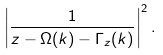Convert formula to latex. <formula><loc_0><loc_0><loc_500><loc_500>\left | \frac { 1 } { z - \Omega ( k ) - \Gamma _ { z } ( k ) } \right | ^ { 2 } .</formula> 